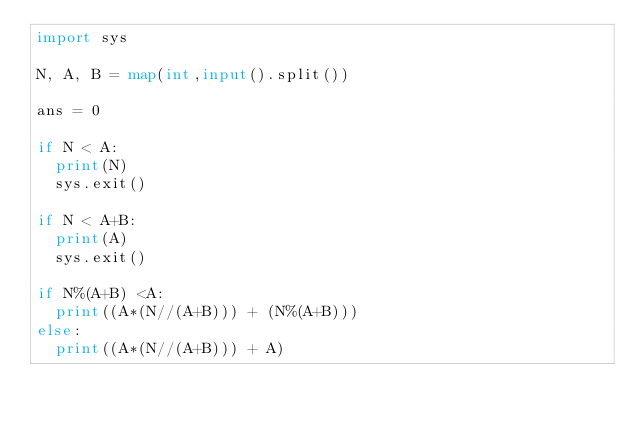<code> <loc_0><loc_0><loc_500><loc_500><_Python_>import sys
 
N, A, B = map(int,input().split())
 
ans = 0
 
if N < A:
  print(N)
  sys.exit()
 
if N < A+B:
  print(A)
  sys.exit()
 
if N%(A+B) <A:
  print((A*(N//(A+B))) + (N%(A+B)))
else:
  print((A*(N//(A+B))) + A)</code> 